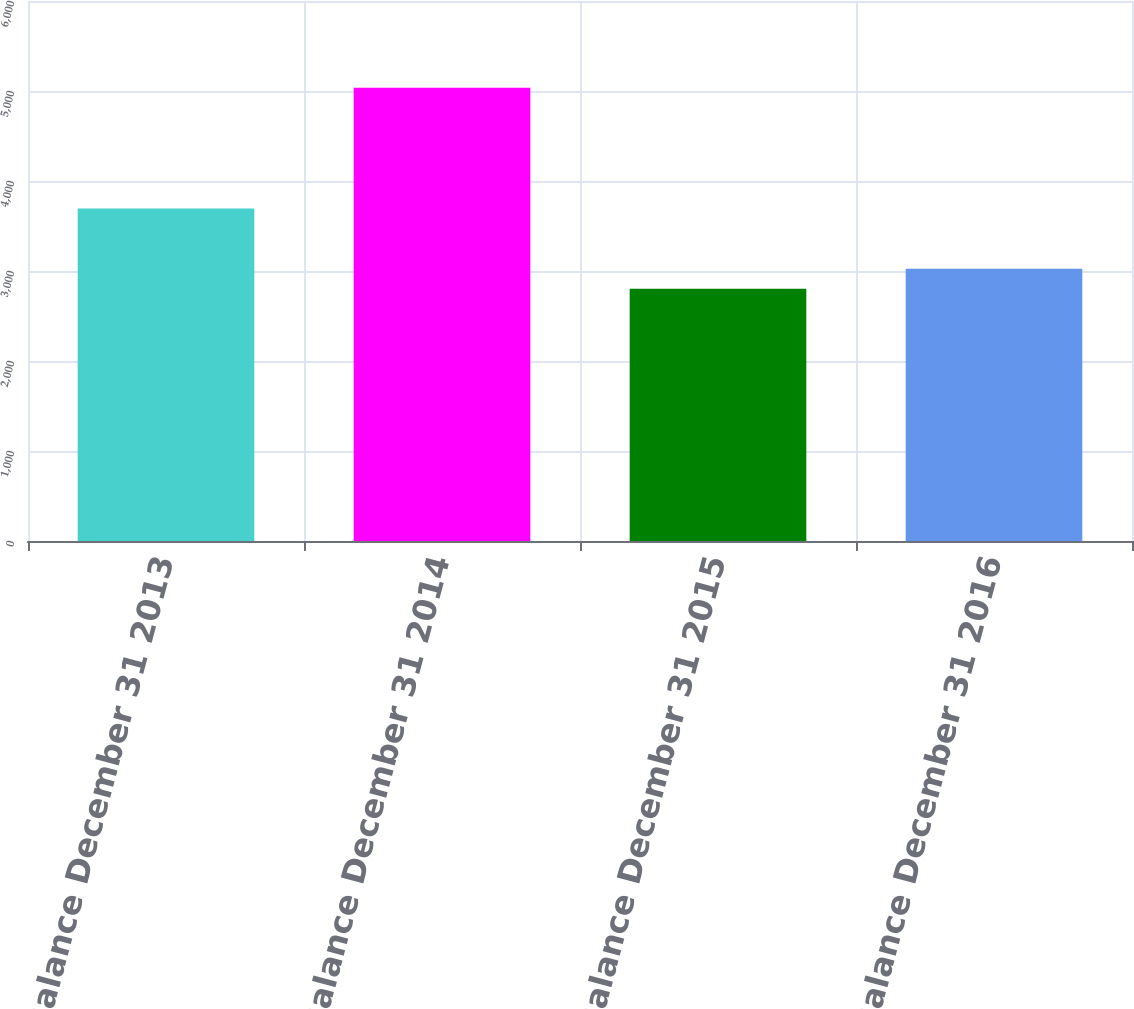Convert chart. <chart><loc_0><loc_0><loc_500><loc_500><bar_chart><fcel>Balance December 31 2013<fcel>Balance December 31 2014<fcel>Balance December 31 2015<fcel>Balance December 31 2016<nl><fcel>3694<fcel>5036<fcel>2802<fcel>3025.4<nl></chart> 